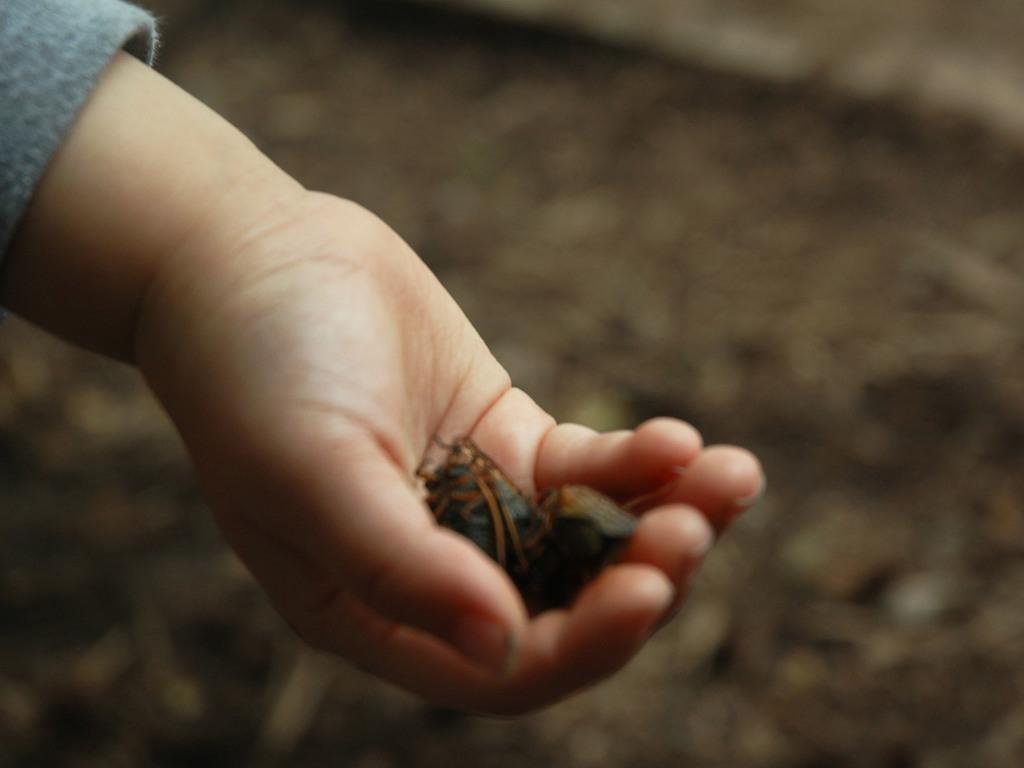Can you describe this image briefly? In this image we can see insects in the hand of a person, the background is blurred. 